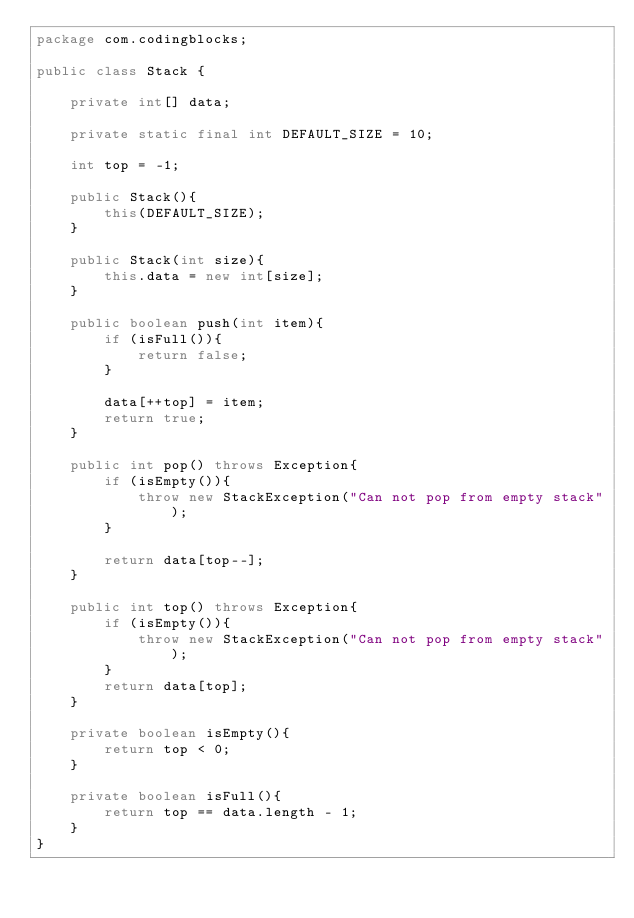<code> <loc_0><loc_0><loc_500><loc_500><_Java_>package com.codingblocks;

public class Stack {

    private int[] data;

    private static final int DEFAULT_SIZE = 10;

    int top = -1;

    public Stack(){
        this(DEFAULT_SIZE);
    }

    public Stack(int size){
        this.data = new int[size];
    }

    public boolean push(int item){
        if (isFull()){
            return false;
        }

        data[++top] = item;
        return true;
    }

    public int pop() throws Exception{
        if (isEmpty()){
            throw new StackException("Can not pop from empty stack");
        }

        return data[top--];
    }

    public int top() throws Exception{
        if (isEmpty()){
            throw new StackException("Can not pop from empty stack");
        }
        return data[top];
    }

    private boolean isEmpty(){
        return top < 0;
    }

    private boolean isFull(){
        return top == data.length - 1;
    }
}
</code> 